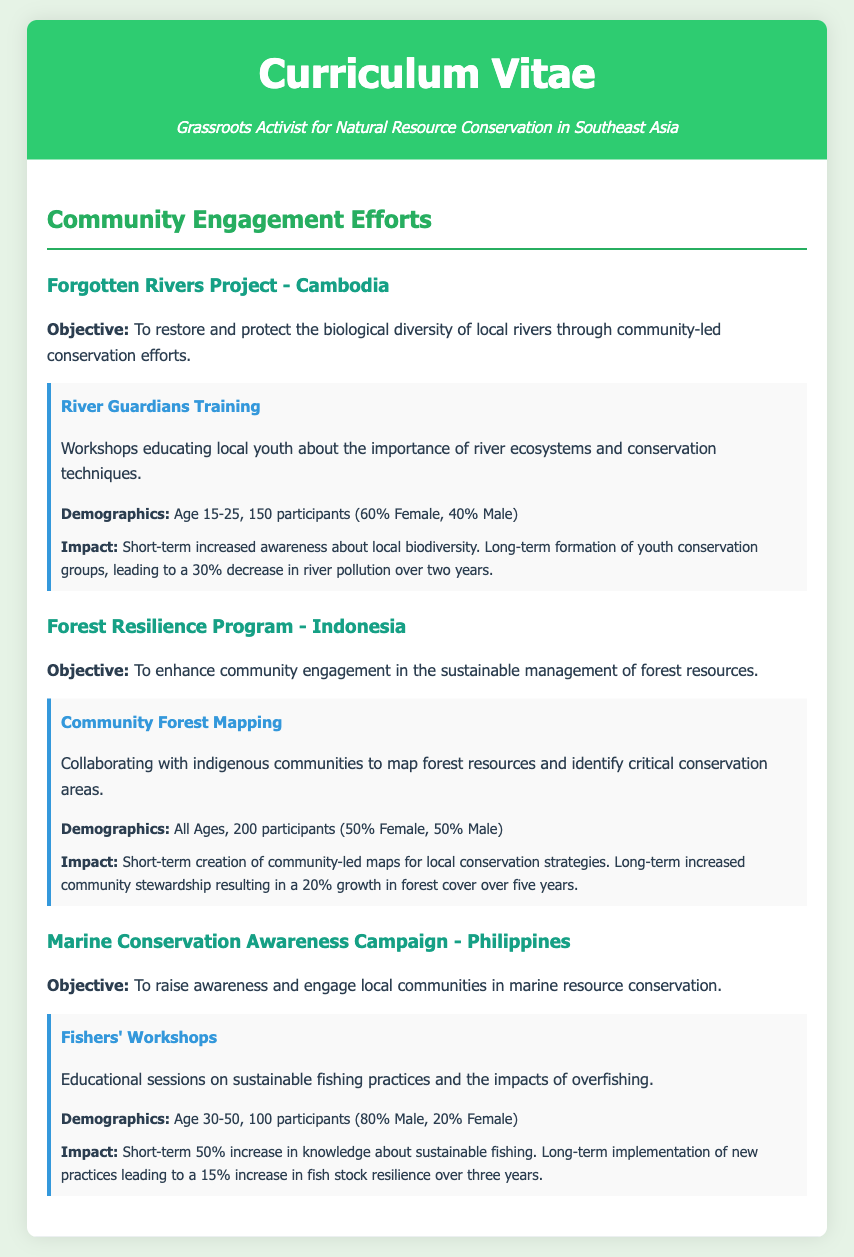What is the objective of the Forgotten Rivers Project? The objective is to restore and protect the biological diversity of local rivers through community-led conservation efforts.
Answer: To restore and protect biological diversity How many participants were involved in the Marine Conservation Awareness Campaign? The document states there were 100 participants in the Fishers' Workshops.
Answer: 100 participants What percentage of participants in the River Guardians Training were female? The demographics indicate that 60% of the 150 participants were female.
Answer: 60% What is the long-term impact assessed for the Forest Resilience Program? The long-term impact includes increased community stewardship resulting in a 20% growth in forest cover over five years.
Answer: 20% growth in forest cover What age group was targeted in the Fishers' Workshops? The demographic information specifies that the target age group was 30-50.
Answer: Age 30-50 What program was implemented under the Forgotten Rivers Project? The program implemented was the River Guardians Training.
Answer: River Guardians Training How many total participants engaged in the Forest Resilience Program? The document states there were 200 participants in the Community Forest Mapping initiative.
Answer: 200 participants What short-term impact was reported for the Marine Conservation Awareness Campaign? The short-term impact noted is a 50% increase in knowledge about sustainable fishing.
Answer: 50% increase in knowledge Which country is associated with the Marine Conservation Awareness Campaign? The program is associated with the Philippines.
Answer: Philippines 